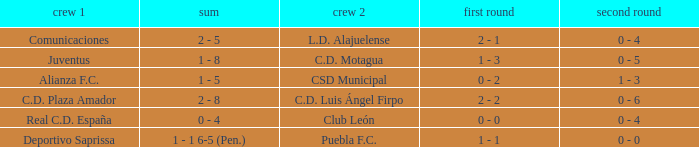What is the 1st leg where Team 1 is C.D. Plaza Amador? 2 - 2. 